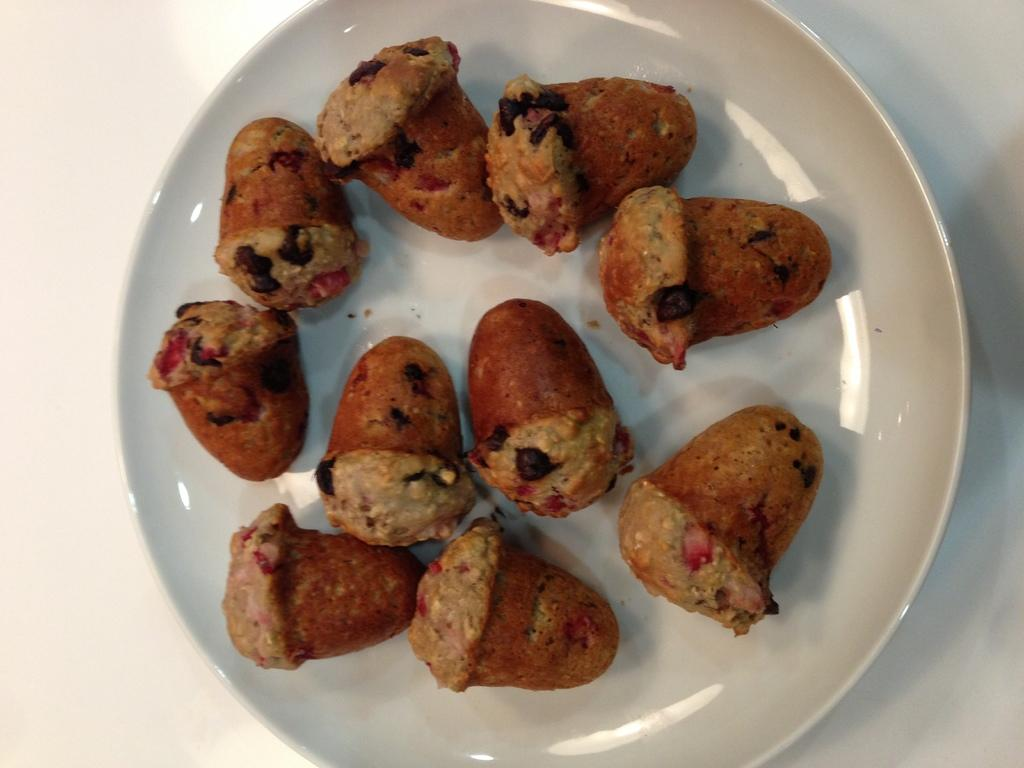What is present on the plate in the image? There is a white plate in the image. What is on the white plate? The white plate is filled with food items. What type of cub is visible on the plate in the image? There is no cub present on the plate in the image. What kind of surprise is hidden within the food items on the plate? There is no mention of a surprise hidden within the food items on the plate. 